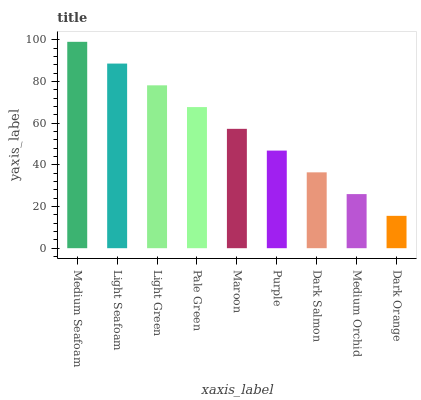Is Dark Orange the minimum?
Answer yes or no. Yes. Is Medium Seafoam the maximum?
Answer yes or no. Yes. Is Light Seafoam the minimum?
Answer yes or no. No. Is Light Seafoam the maximum?
Answer yes or no. No. Is Medium Seafoam greater than Light Seafoam?
Answer yes or no. Yes. Is Light Seafoam less than Medium Seafoam?
Answer yes or no. Yes. Is Light Seafoam greater than Medium Seafoam?
Answer yes or no. No. Is Medium Seafoam less than Light Seafoam?
Answer yes or no. No. Is Maroon the high median?
Answer yes or no. Yes. Is Maroon the low median?
Answer yes or no. Yes. Is Dark Orange the high median?
Answer yes or no. No. Is Light Seafoam the low median?
Answer yes or no. No. 